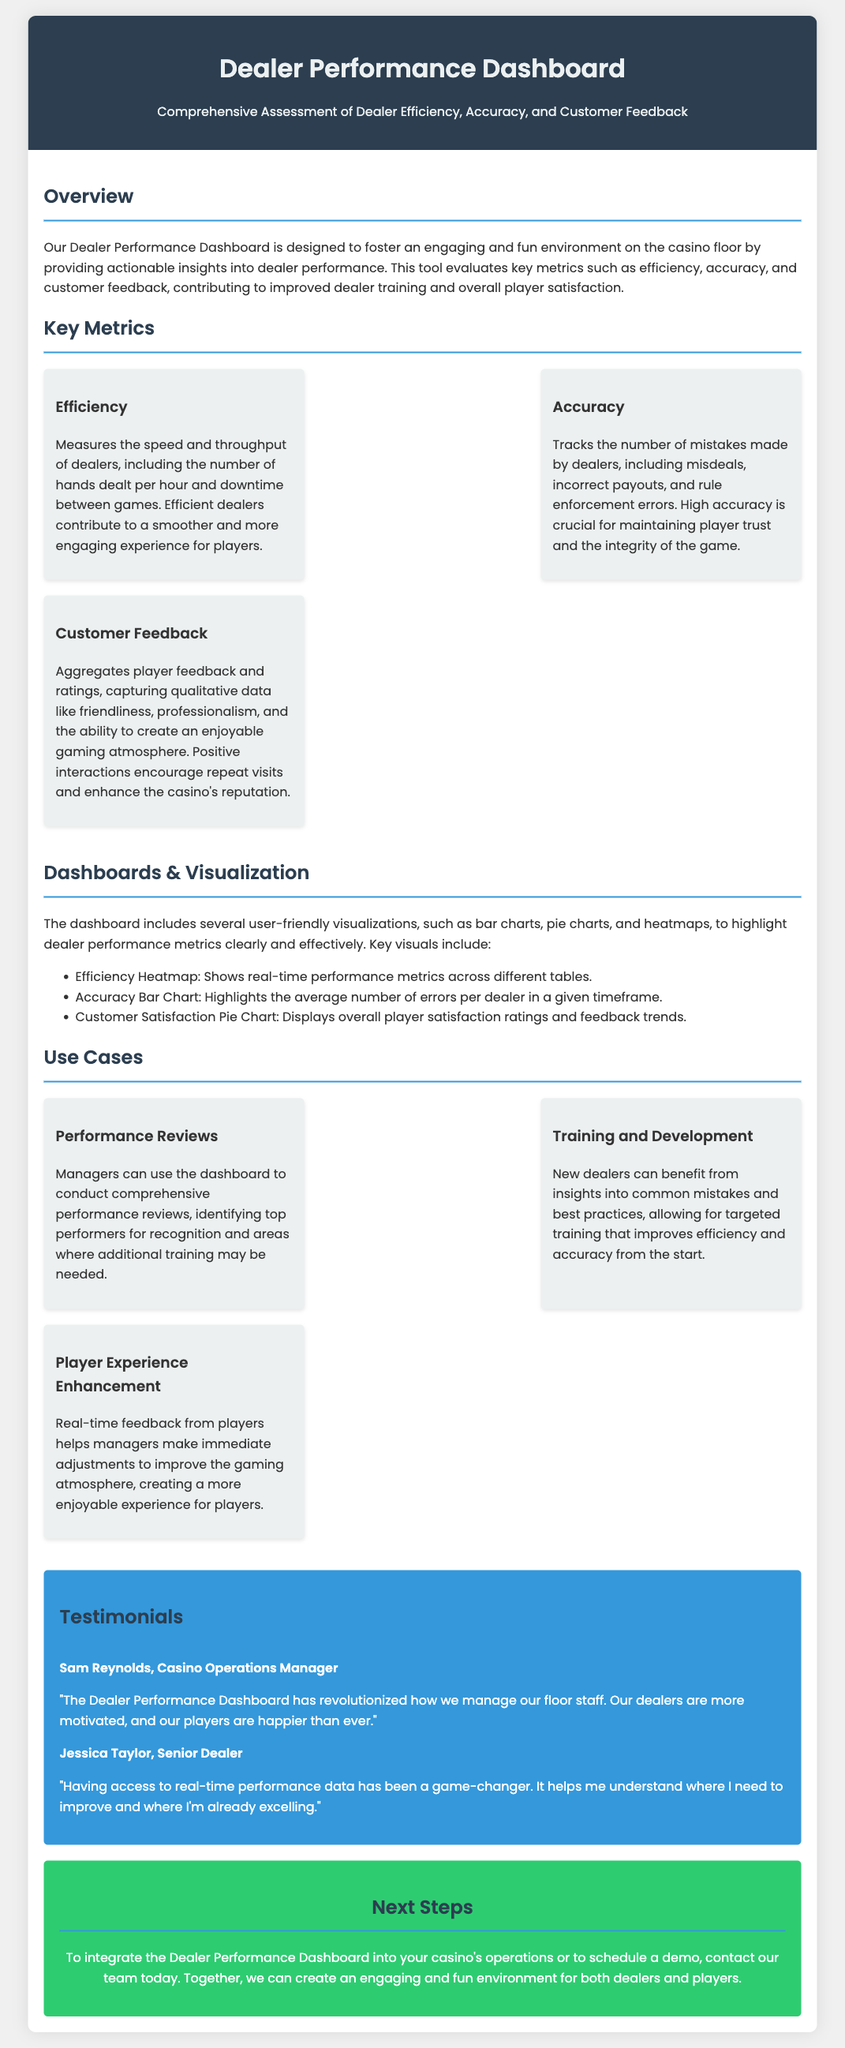What is the title of the dashboard? The title of the dashboard is provided in the header section of the document.
Answer: Dealer Performance Dashboard What are the three key metrics assessed? The key metrics are mentioned in the "Key Metrics" section and are Efficiency, Accuracy, and Customer Feedback.
Answer: Efficiency, Accuracy, Customer Feedback What visualization highlights the average number of errors per dealer? The document specifies the types of visualizations available, including which one focuses on dealer errors.
Answer: Accuracy Bar Chart Who provided a testimonial regarding the dashboard? The testimonials section lists individuals who shared their experiences, including their names.
Answer: Sam Reynolds, Jessica Taylor What is a use case for training and development? The "Use Cases" section explains how the dashboard can support training and development for new dealers.
Answer: Insights into common mistakes and best practices How does the dashboard enhance player experience? The document describes how real-time feedback affects player experience in the "Use Cases" section.
Answer: Immediate adjustments to improve the gaming atmosphere How is the data displayed in the dashboard? The document mentions the types of visual presentations available in the dashboard for dealer performance metrics.
Answer: Bar charts, pie charts, heatmaps What color scheme is used for the testimonials section? The color scheme is explicitly described in the section dedicated to testimonials.
Answer: Blue 